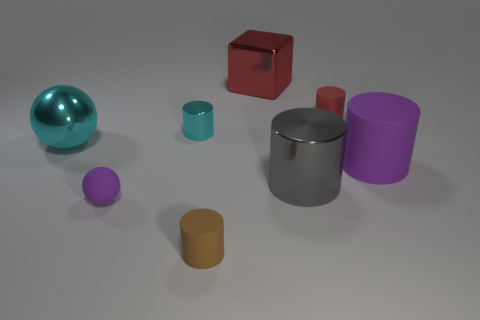Are there any other things of the same color as the tiny rubber ball?
Give a very brief answer. Yes. Do the large thing to the left of the tiny matte sphere and the small shiny cylinder have the same color?
Offer a terse response. Yes. There is a large shiny object that is the same shape as the tiny red thing; what is its color?
Your answer should be very brief. Gray. How many objects are large red metallic objects on the left side of the gray shiny thing or tiny rubber things that are on the left side of the brown rubber thing?
Your response must be concise. 2. What is the shape of the small cyan thing?
Make the answer very short. Cylinder. What is the shape of the other rubber object that is the same color as the large rubber object?
Offer a terse response. Sphere. How many small cyan things are made of the same material as the cyan cylinder?
Ensure brevity in your answer.  0. The small shiny cylinder is what color?
Provide a short and direct response. Cyan. What color is the rubber cylinder that is the same size as the gray object?
Your answer should be compact. Purple. Are there any tiny shiny cylinders of the same color as the large shiny ball?
Provide a short and direct response. Yes. 